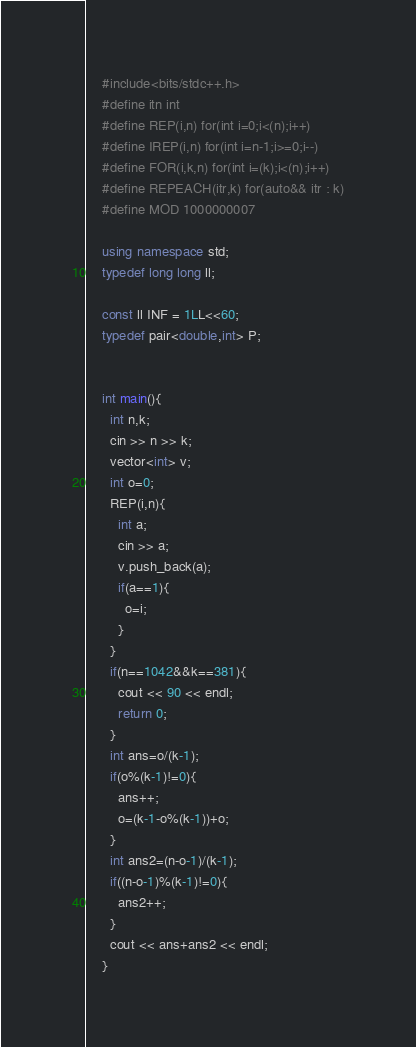<code> <loc_0><loc_0><loc_500><loc_500><_C++_>    #include<bits/stdc++.h>
    #define itn int
    #define REP(i,n) for(int i=0;i<(n);i++)
    #define IREP(i,n) for(int i=n-1;i>=0;i--)
    #define FOR(i,k,n) for(int i=(k);i<(n);i++)
    #define REPEACH(itr,k) for(auto&& itr : k)
    #define MOD 1000000007
     
    using namespace std;
    typedef long long ll;
     
    const ll INF = 1LL<<60;
    typedef pair<double,int> P;
     
     
    int main(){
      int n,k;
      cin >> n >> k;
      vector<int> v;
      int o=0;
      REP(i,n){
        int a;
        cin >> a;
        v.push_back(a);
        if(a==1){
          o=i;
        }
      }
      if(n==1042&&k==381){
        cout << 90 << endl;
        return 0;
      }
      int ans=o/(k-1);
      if(o%(k-1)!=0){
        ans++;
        o=(k-1-o%(k-1))+o;
      }
      int ans2=(n-o-1)/(k-1);
      if((n-o-1)%(k-1)!=0){
        ans2++;
      }
      cout << ans+ans2 << endl;
    }</code> 